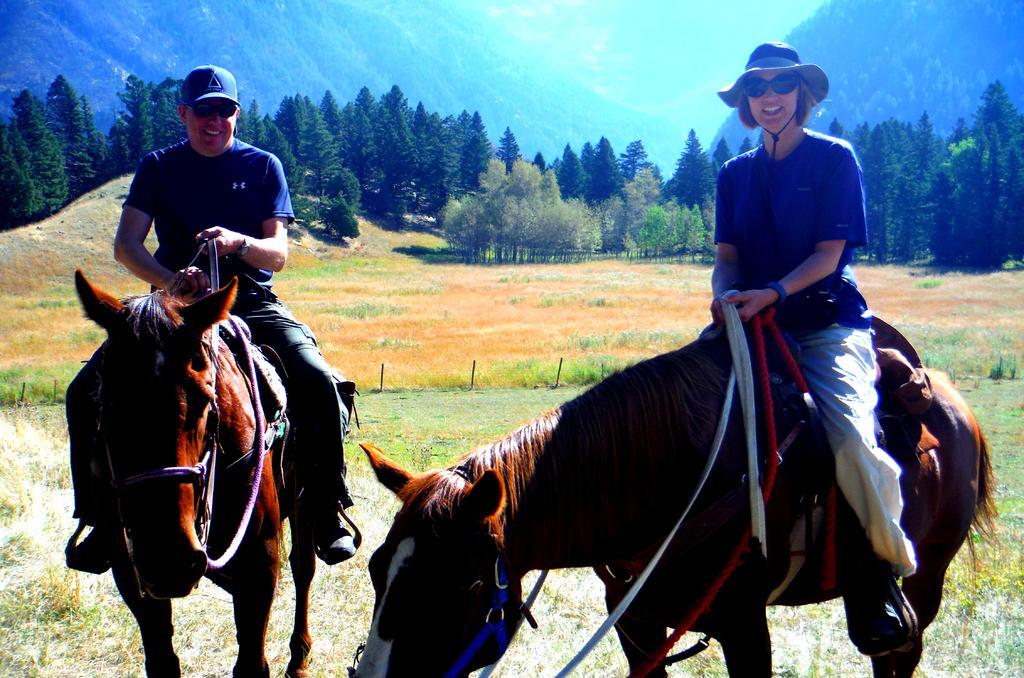Describe this image in one or two sentences. In this image we can see two persons sitting on the horses, in the background, we can see some trees, grass, mountains and the sky. 